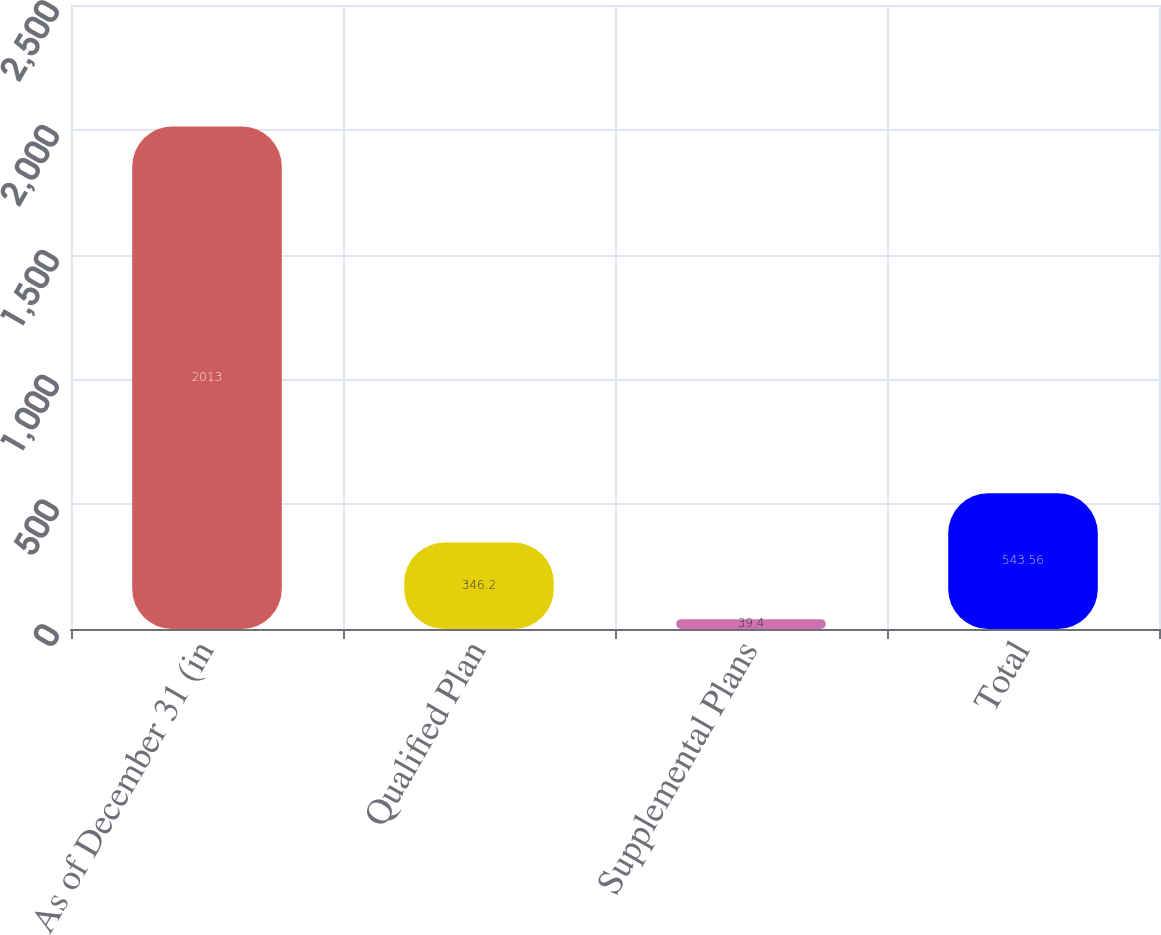<chart> <loc_0><loc_0><loc_500><loc_500><bar_chart><fcel>As of December 31 (in<fcel>Qualified Plan<fcel>Supplemental Plans<fcel>Total<nl><fcel>2013<fcel>346.2<fcel>39.4<fcel>543.56<nl></chart> 